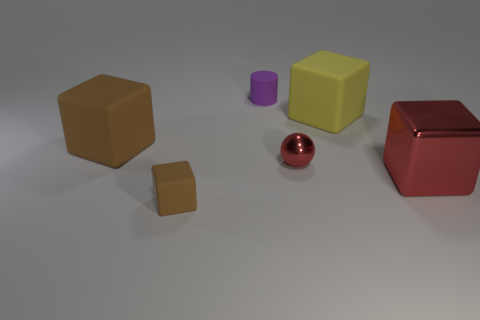There is a brown rubber block that is in front of the brown rubber block behind the large red object; are there any large matte cubes right of it?
Your answer should be very brief. Yes. Is the number of yellow rubber cubes that are in front of the large brown block less than the number of blocks that are behind the sphere?
Give a very brief answer. Yes. There is a small cube that is made of the same material as the yellow thing; what color is it?
Offer a terse response. Brown. What is the color of the object on the left side of the brown rubber thing in front of the large metal cube?
Offer a very short reply. Brown. Are there any matte objects of the same color as the small matte cube?
Make the answer very short. Yes. The brown rubber object that is the same size as the yellow rubber block is what shape?
Make the answer very short. Cube. How many big matte cubes are on the left side of the tiny rubber thing that is left of the small matte cylinder?
Ensure brevity in your answer.  1. Is the color of the metallic cube the same as the matte cylinder?
Ensure brevity in your answer.  No. What number of other objects are the same material as the large brown block?
Ensure brevity in your answer.  3. There is a tiny object in front of the large block in front of the red shiny sphere; what shape is it?
Ensure brevity in your answer.  Cube. 